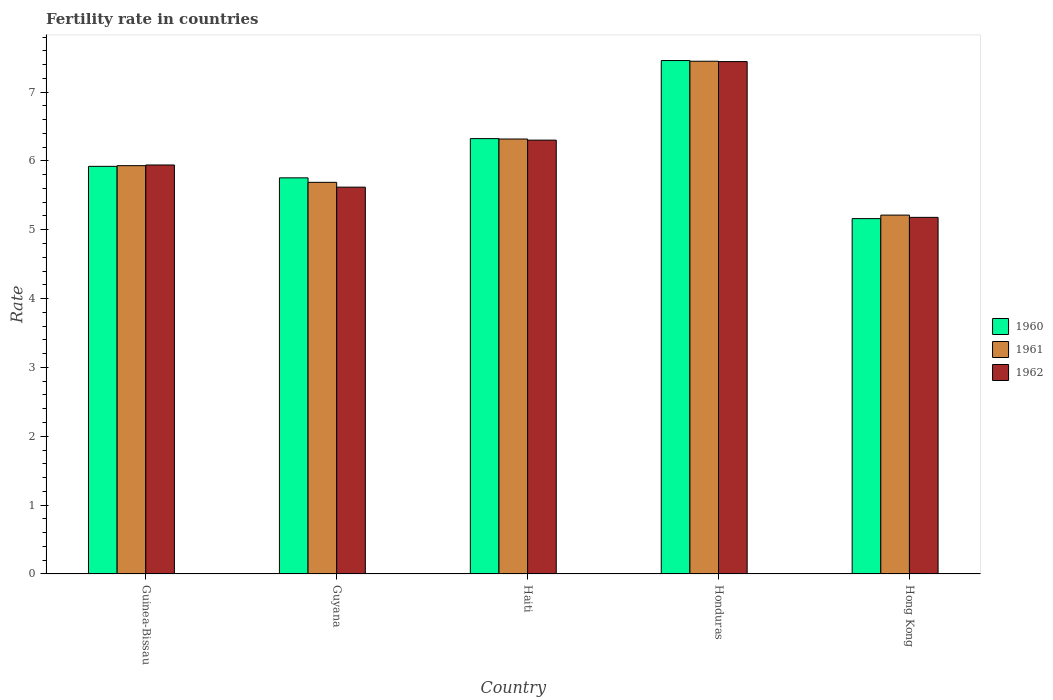How many different coloured bars are there?
Offer a very short reply. 3. Are the number of bars per tick equal to the number of legend labels?
Provide a short and direct response. Yes. How many bars are there on the 4th tick from the left?
Give a very brief answer. 3. What is the label of the 4th group of bars from the left?
Provide a succinct answer. Honduras. What is the fertility rate in 1962 in Guinea-Bissau?
Provide a succinct answer. 5.94. Across all countries, what is the maximum fertility rate in 1960?
Give a very brief answer. 7.46. Across all countries, what is the minimum fertility rate in 1960?
Your response must be concise. 5.16. In which country was the fertility rate in 1961 maximum?
Keep it short and to the point. Honduras. In which country was the fertility rate in 1961 minimum?
Give a very brief answer. Hong Kong. What is the total fertility rate in 1962 in the graph?
Your answer should be very brief. 30.48. What is the difference between the fertility rate in 1960 in Guyana and that in Honduras?
Provide a succinct answer. -1.7. What is the difference between the fertility rate in 1960 in Hong Kong and the fertility rate in 1961 in Guinea-Bissau?
Keep it short and to the point. -0.77. What is the average fertility rate in 1961 per country?
Keep it short and to the point. 6.12. What is the difference between the fertility rate of/in 1960 and fertility rate of/in 1961 in Hong Kong?
Ensure brevity in your answer.  -0.05. In how many countries, is the fertility rate in 1960 greater than 4.6?
Ensure brevity in your answer.  5. What is the ratio of the fertility rate in 1962 in Honduras to that in Hong Kong?
Provide a short and direct response. 1.44. What is the difference between the highest and the second highest fertility rate in 1960?
Offer a very short reply. -0.4. What is the difference between the highest and the lowest fertility rate in 1961?
Ensure brevity in your answer.  2.23. Is the sum of the fertility rate in 1960 in Guinea-Bissau and Hong Kong greater than the maximum fertility rate in 1961 across all countries?
Your answer should be compact. Yes. How many bars are there?
Your answer should be compact. 15. How many countries are there in the graph?
Provide a succinct answer. 5. Does the graph contain any zero values?
Offer a terse response. No. Does the graph contain grids?
Keep it short and to the point. No. How many legend labels are there?
Give a very brief answer. 3. What is the title of the graph?
Ensure brevity in your answer.  Fertility rate in countries. What is the label or title of the X-axis?
Keep it short and to the point. Country. What is the label or title of the Y-axis?
Make the answer very short. Rate. What is the Rate in 1960 in Guinea-Bissau?
Your answer should be very brief. 5.92. What is the Rate of 1961 in Guinea-Bissau?
Provide a short and direct response. 5.93. What is the Rate in 1962 in Guinea-Bissau?
Offer a very short reply. 5.94. What is the Rate of 1960 in Guyana?
Ensure brevity in your answer.  5.75. What is the Rate of 1961 in Guyana?
Your answer should be compact. 5.69. What is the Rate in 1962 in Guyana?
Provide a short and direct response. 5.62. What is the Rate in 1960 in Haiti?
Keep it short and to the point. 6.32. What is the Rate of 1961 in Haiti?
Offer a very short reply. 6.32. What is the Rate of 1962 in Haiti?
Provide a short and direct response. 6.3. What is the Rate of 1960 in Honduras?
Make the answer very short. 7.46. What is the Rate in 1961 in Honduras?
Your answer should be very brief. 7.45. What is the Rate of 1962 in Honduras?
Your answer should be compact. 7.44. What is the Rate in 1960 in Hong Kong?
Offer a terse response. 5.16. What is the Rate in 1961 in Hong Kong?
Provide a short and direct response. 5.21. What is the Rate of 1962 in Hong Kong?
Your answer should be very brief. 5.18. Across all countries, what is the maximum Rate in 1960?
Keep it short and to the point. 7.46. Across all countries, what is the maximum Rate of 1961?
Your answer should be very brief. 7.45. Across all countries, what is the maximum Rate in 1962?
Your answer should be very brief. 7.44. Across all countries, what is the minimum Rate in 1960?
Make the answer very short. 5.16. Across all countries, what is the minimum Rate in 1961?
Provide a short and direct response. 5.21. Across all countries, what is the minimum Rate of 1962?
Ensure brevity in your answer.  5.18. What is the total Rate in 1960 in the graph?
Your response must be concise. 30.62. What is the total Rate in 1961 in the graph?
Offer a very short reply. 30.6. What is the total Rate of 1962 in the graph?
Offer a very short reply. 30.48. What is the difference between the Rate of 1960 in Guinea-Bissau and that in Guyana?
Offer a terse response. 0.17. What is the difference between the Rate in 1961 in Guinea-Bissau and that in Guyana?
Give a very brief answer. 0.24. What is the difference between the Rate in 1962 in Guinea-Bissau and that in Guyana?
Make the answer very short. 0.32. What is the difference between the Rate of 1960 in Guinea-Bissau and that in Haiti?
Ensure brevity in your answer.  -0.4. What is the difference between the Rate of 1961 in Guinea-Bissau and that in Haiti?
Make the answer very short. -0.39. What is the difference between the Rate of 1962 in Guinea-Bissau and that in Haiti?
Ensure brevity in your answer.  -0.36. What is the difference between the Rate in 1960 in Guinea-Bissau and that in Honduras?
Ensure brevity in your answer.  -1.54. What is the difference between the Rate in 1961 in Guinea-Bissau and that in Honduras?
Provide a short and direct response. -1.52. What is the difference between the Rate in 1962 in Guinea-Bissau and that in Honduras?
Provide a short and direct response. -1.5. What is the difference between the Rate in 1960 in Guinea-Bissau and that in Hong Kong?
Keep it short and to the point. 0.76. What is the difference between the Rate of 1961 in Guinea-Bissau and that in Hong Kong?
Your response must be concise. 0.72. What is the difference between the Rate of 1962 in Guinea-Bissau and that in Hong Kong?
Provide a succinct answer. 0.76. What is the difference between the Rate of 1960 in Guyana and that in Haiti?
Offer a terse response. -0.57. What is the difference between the Rate in 1961 in Guyana and that in Haiti?
Give a very brief answer. -0.63. What is the difference between the Rate in 1962 in Guyana and that in Haiti?
Offer a terse response. -0.68. What is the difference between the Rate of 1960 in Guyana and that in Honduras?
Offer a terse response. -1.7. What is the difference between the Rate of 1961 in Guyana and that in Honduras?
Make the answer very short. -1.76. What is the difference between the Rate in 1962 in Guyana and that in Honduras?
Offer a very short reply. -1.82. What is the difference between the Rate of 1960 in Guyana and that in Hong Kong?
Provide a short and direct response. 0.59. What is the difference between the Rate in 1961 in Guyana and that in Hong Kong?
Your response must be concise. 0.48. What is the difference between the Rate of 1962 in Guyana and that in Hong Kong?
Provide a short and direct response. 0.44. What is the difference between the Rate of 1960 in Haiti and that in Honduras?
Keep it short and to the point. -1.13. What is the difference between the Rate of 1961 in Haiti and that in Honduras?
Offer a very short reply. -1.13. What is the difference between the Rate of 1962 in Haiti and that in Honduras?
Offer a very short reply. -1.14. What is the difference between the Rate in 1960 in Haiti and that in Hong Kong?
Your answer should be compact. 1.16. What is the difference between the Rate in 1961 in Haiti and that in Hong Kong?
Keep it short and to the point. 1.1. What is the difference between the Rate of 1962 in Haiti and that in Hong Kong?
Give a very brief answer. 1.12. What is the difference between the Rate of 1960 in Honduras and that in Hong Kong?
Your answer should be very brief. 2.3. What is the difference between the Rate of 1961 in Honduras and that in Hong Kong?
Your answer should be very brief. 2.23. What is the difference between the Rate in 1962 in Honduras and that in Hong Kong?
Offer a terse response. 2.26. What is the difference between the Rate in 1960 in Guinea-Bissau and the Rate in 1961 in Guyana?
Make the answer very short. 0.23. What is the difference between the Rate of 1960 in Guinea-Bissau and the Rate of 1962 in Guyana?
Provide a short and direct response. 0.3. What is the difference between the Rate in 1961 in Guinea-Bissau and the Rate in 1962 in Guyana?
Ensure brevity in your answer.  0.31. What is the difference between the Rate of 1960 in Guinea-Bissau and the Rate of 1961 in Haiti?
Keep it short and to the point. -0.4. What is the difference between the Rate in 1960 in Guinea-Bissau and the Rate in 1962 in Haiti?
Ensure brevity in your answer.  -0.38. What is the difference between the Rate in 1961 in Guinea-Bissau and the Rate in 1962 in Haiti?
Your answer should be very brief. -0.37. What is the difference between the Rate in 1960 in Guinea-Bissau and the Rate in 1961 in Honduras?
Your answer should be very brief. -1.53. What is the difference between the Rate in 1960 in Guinea-Bissau and the Rate in 1962 in Honduras?
Your response must be concise. -1.52. What is the difference between the Rate in 1961 in Guinea-Bissau and the Rate in 1962 in Honduras?
Your answer should be very brief. -1.51. What is the difference between the Rate of 1960 in Guinea-Bissau and the Rate of 1961 in Hong Kong?
Keep it short and to the point. 0.71. What is the difference between the Rate in 1960 in Guinea-Bissau and the Rate in 1962 in Hong Kong?
Give a very brief answer. 0.74. What is the difference between the Rate in 1961 in Guinea-Bissau and the Rate in 1962 in Hong Kong?
Your answer should be very brief. 0.75. What is the difference between the Rate in 1960 in Guyana and the Rate in 1961 in Haiti?
Keep it short and to the point. -0.56. What is the difference between the Rate in 1960 in Guyana and the Rate in 1962 in Haiti?
Offer a very short reply. -0.55. What is the difference between the Rate in 1961 in Guyana and the Rate in 1962 in Haiti?
Provide a short and direct response. -0.61. What is the difference between the Rate in 1960 in Guyana and the Rate in 1961 in Honduras?
Your response must be concise. -1.69. What is the difference between the Rate of 1960 in Guyana and the Rate of 1962 in Honduras?
Give a very brief answer. -1.69. What is the difference between the Rate in 1961 in Guyana and the Rate in 1962 in Honduras?
Offer a terse response. -1.75. What is the difference between the Rate of 1960 in Guyana and the Rate of 1961 in Hong Kong?
Your answer should be compact. 0.54. What is the difference between the Rate of 1960 in Guyana and the Rate of 1962 in Hong Kong?
Your response must be concise. 0.57. What is the difference between the Rate of 1961 in Guyana and the Rate of 1962 in Hong Kong?
Provide a succinct answer. 0.51. What is the difference between the Rate in 1960 in Haiti and the Rate in 1961 in Honduras?
Provide a short and direct response. -1.12. What is the difference between the Rate of 1960 in Haiti and the Rate of 1962 in Honduras?
Your response must be concise. -1.12. What is the difference between the Rate of 1961 in Haiti and the Rate of 1962 in Honduras?
Make the answer very short. -1.12. What is the difference between the Rate of 1960 in Haiti and the Rate of 1961 in Hong Kong?
Make the answer very short. 1.11. What is the difference between the Rate of 1960 in Haiti and the Rate of 1962 in Hong Kong?
Make the answer very short. 1.14. What is the difference between the Rate in 1961 in Haiti and the Rate in 1962 in Hong Kong?
Provide a short and direct response. 1.14. What is the difference between the Rate of 1960 in Honduras and the Rate of 1961 in Hong Kong?
Give a very brief answer. 2.25. What is the difference between the Rate in 1960 in Honduras and the Rate in 1962 in Hong Kong?
Make the answer very short. 2.28. What is the difference between the Rate of 1961 in Honduras and the Rate of 1962 in Hong Kong?
Ensure brevity in your answer.  2.27. What is the average Rate of 1960 per country?
Your response must be concise. 6.12. What is the average Rate in 1961 per country?
Your answer should be very brief. 6.12. What is the average Rate of 1962 per country?
Your response must be concise. 6.1. What is the difference between the Rate in 1960 and Rate in 1961 in Guinea-Bissau?
Keep it short and to the point. -0.01. What is the difference between the Rate in 1960 and Rate in 1962 in Guinea-Bissau?
Offer a terse response. -0.02. What is the difference between the Rate in 1961 and Rate in 1962 in Guinea-Bissau?
Make the answer very short. -0.01. What is the difference between the Rate of 1960 and Rate of 1961 in Guyana?
Your answer should be very brief. 0.07. What is the difference between the Rate in 1960 and Rate in 1962 in Guyana?
Offer a terse response. 0.14. What is the difference between the Rate in 1961 and Rate in 1962 in Guyana?
Your response must be concise. 0.07. What is the difference between the Rate in 1960 and Rate in 1961 in Haiti?
Ensure brevity in your answer.  0.01. What is the difference between the Rate in 1960 and Rate in 1962 in Haiti?
Offer a terse response. 0.02. What is the difference between the Rate in 1961 and Rate in 1962 in Haiti?
Provide a succinct answer. 0.02. What is the difference between the Rate in 1960 and Rate in 1961 in Honduras?
Provide a short and direct response. 0.01. What is the difference between the Rate in 1960 and Rate in 1962 in Honduras?
Offer a very short reply. 0.01. What is the difference between the Rate of 1961 and Rate of 1962 in Honduras?
Keep it short and to the point. 0.01. What is the difference between the Rate of 1960 and Rate of 1961 in Hong Kong?
Your response must be concise. -0.05. What is the difference between the Rate of 1960 and Rate of 1962 in Hong Kong?
Your response must be concise. -0.02. What is the difference between the Rate of 1961 and Rate of 1962 in Hong Kong?
Your answer should be very brief. 0.03. What is the ratio of the Rate of 1961 in Guinea-Bissau to that in Guyana?
Offer a very short reply. 1.04. What is the ratio of the Rate in 1962 in Guinea-Bissau to that in Guyana?
Keep it short and to the point. 1.06. What is the ratio of the Rate of 1960 in Guinea-Bissau to that in Haiti?
Provide a succinct answer. 0.94. What is the ratio of the Rate of 1961 in Guinea-Bissau to that in Haiti?
Provide a short and direct response. 0.94. What is the ratio of the Rate in 1962 in Guinea-Bissau to that in Haiti?
Provide a succinct answer. 0.94. What is the ratio of the Rate of 1960 in Guinea-Bissau to that in Honduras?
Ensure brevity in your answer.  0.79. What is the ratio of the Rate of 1961 in Guinea-Bissau to that in Honduras?
Keep it short and to the point. 0.8. What is the ratio of the Rate of 1962 in Guinea-Bissau to that in Honduras?
Ensure brevity in your answer.  0.8. What is the ratio of the Rate of 1960 in Guinea-Bissau to that in Hong Kong?
Provide a short and direct response. 1.15. What is the ratio of the Rate in 1961 in Guinea-Bissau to that in Hong Kong?
Keep it short and to the point. 1.14. What is the ratio of the Rate in 1962 in Guinea-Bissau to that in Hong Kong?
Keep it short and to the point. 1.15. What is the ratio of the Rate of 1960 in Guyana to that in Haiti?
Give a very brief answer. 0.91. What is the ratio of the Rate in 1961 in Guyana to that in Haiti?
Provide a short and direct response. 0.9. What is the ratio of the Rate in 1962 in Guyana to that in Haiti?
Your answer should be compact. 0.89. What is the ratio of the Rate in 1960 in Guyana to that in Honduras?
Give a very brief answer. 0.77. What is the ratio of the Rate of 1961 in Guyana to that in Honduras?
Give a very brief answer. 0.76. What is the ratio of the Rate in 1962 in Guyana to that in Honduras?
Your response must be concise. 0.75. What is the ratio of the Rate in 1960 in Guyana to that in Hong Kong?
Your answer should be very brief. 1.11. What is the ratio of the Rate of 1961 in Guyana to that in Hong Kong?
Make the answer very short. 1.09. What is the ratio of the Rate of 1962 in Guyana to that in Hong Kong?
Give a very brief answer. 1.08. What is the ratio of the Rate in 1960 in Haiti to that in Honduras?
Make the answer very short. 0.85. What is the ratio of the Rate of 1961 in Haiti to that in Honduras?
Offer a terse response. 0.85. What is the ratio of the Rate of 1962 in Haiti to that in Honduras?
Your answer should be compact. 0.85. What is the ratio of the Rate in 1960 in Haiti to that in Hong Kong?
Provide a succinct answer. 1.23. What is the ratio of the Rate in 1961 in Haiti to that in Hong Kong?
Ensure brevity in your answer.  1.21. What is the ratio of the Rate in 1962 in Haiti to that in Hong Kong?
Keep it short and to the point. 1.22. What is the ratio of the Rate in 1960 in Honduras to that in Hong Kong?
Offer a terse response. 1.44. What is the ratio of the Rate of 1961 in Honduras to that in Hong Kong?
Give a very brief answer. 1.43. What is the ratio of the Rate in 1962 in Honduras to that in Hong Kong?
Provide a succinct answer. 1.44. What is the difference between the highest and the second highest Rate in 1960?
Keep it short and to the point. 1.13. What is the difference between the highest and the second highest Rate in 1961?
Offer a terse response. 1.13. What is the difference between the highest and the second highest Rate of 1962?
Your answer should be compact. 1.14. What is the difference between the highest and the lowest Rate in 1960?
Provide a succinct answer. 2.3. What is the difference between the highest and the lowest Rate in 1961?
Your answer should be compact. 2.23. What is the difference between the highest and the lowest Rate in 1962?
Make the answer very short. 2.26. 